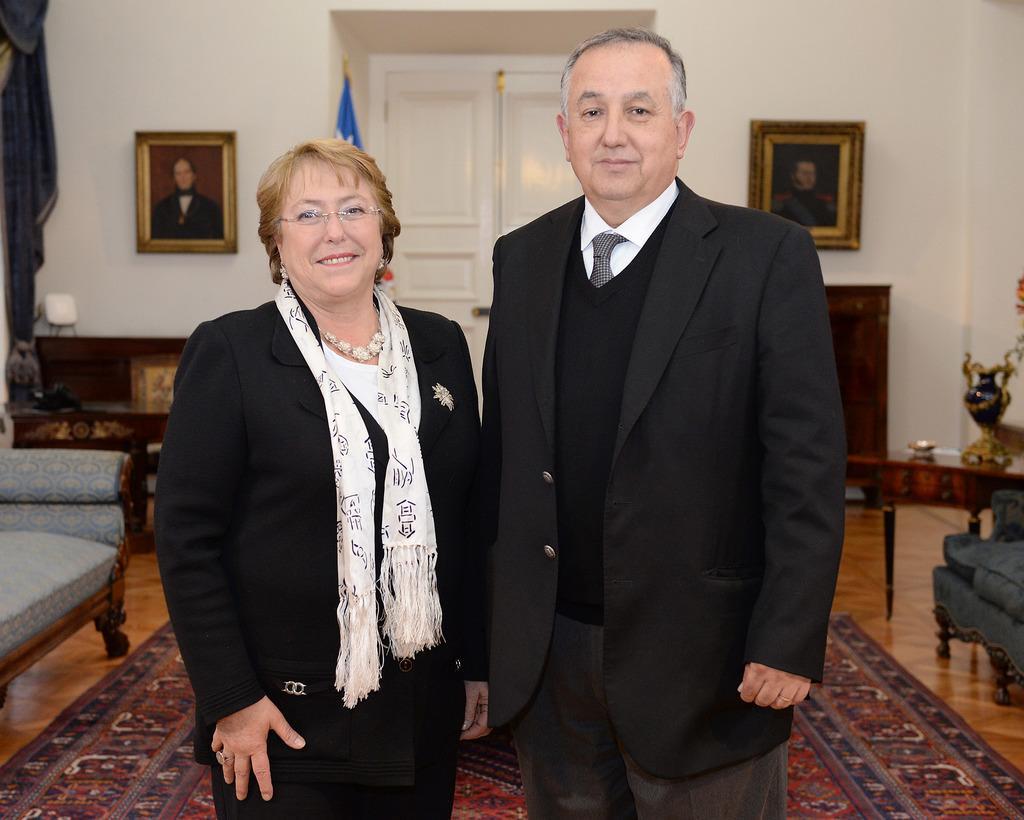How would you summarize this image in a sentence or two? In the foreground of this image, there is a couple in black color dress standing on the floor. In the background, we can see couches, carpet, floor, table, flower vase, photo frames, a flag, wall and the door. 